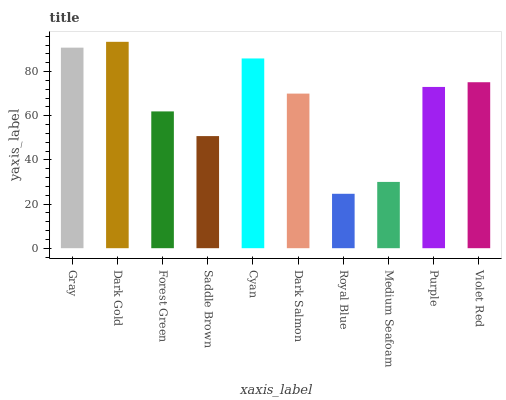Is Royal Blue the minimum?
Answer yes or no. Yes. Is Dark Gold the maximum?
Answer yes or no. Yes. Is Forest Green the minimum?
Answer yes or no. No. Is Forest Green the maximum?
Answer yes or no. No. Is Dark Gold greater than Forest Green?
Answer yes or no. Yes. Is Forest Green less than Dark Gold?
Answer yes or no. Yes. Is Forest Green greater than Dark Gold?
Answer yes or no. No. Is Dark Gold less than Forest Green?
Answer yes or no. No. Is Purple the high median?
Answer yes or no. Yes. Is Dark Salmon the low median?
Answer yes or no. Yes. Is Dark Gold the high median?
Answer yes or no. No. Is Forest Green the low median?
Answer yes or no. No. 